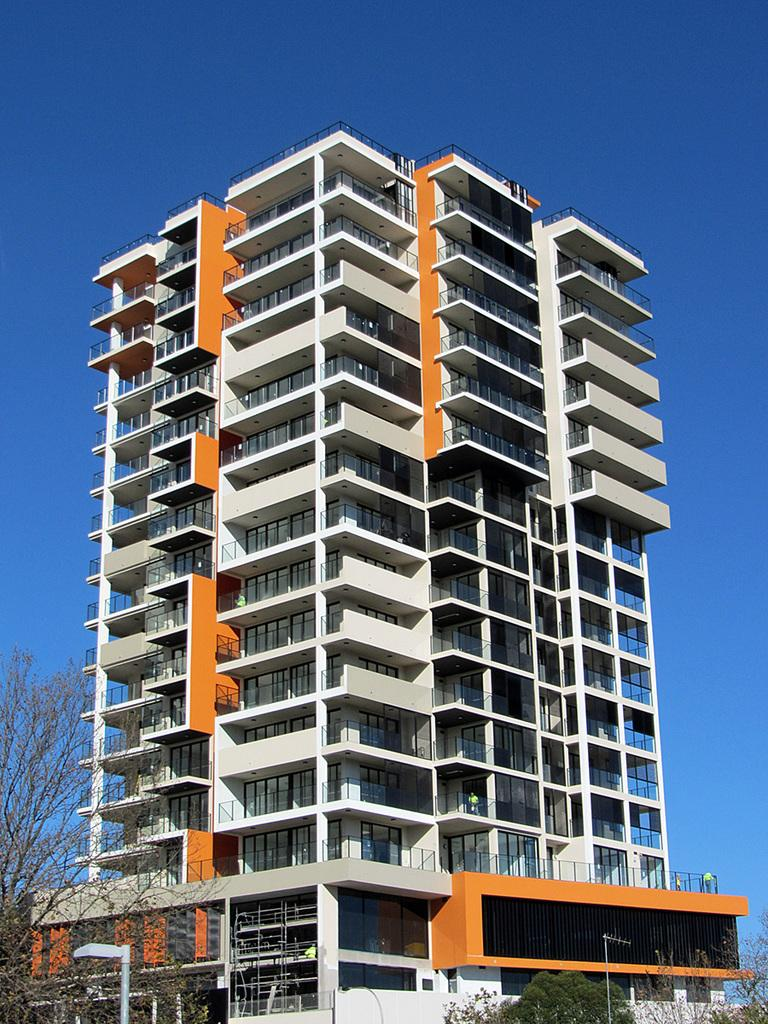What type of structure is the main subject of the image? There is a tower building with many floors in the image. What can be seen near the tower building? There are trees and plants near the tower building. What is visible in the background of the image? The sky is visible in the background of the image. What color is the sky in the image? The sky is blue in color. What type of sponge is being used to clean the windows of the tower building in the image? There is no sponge or window cleaning activity visible in the image. 